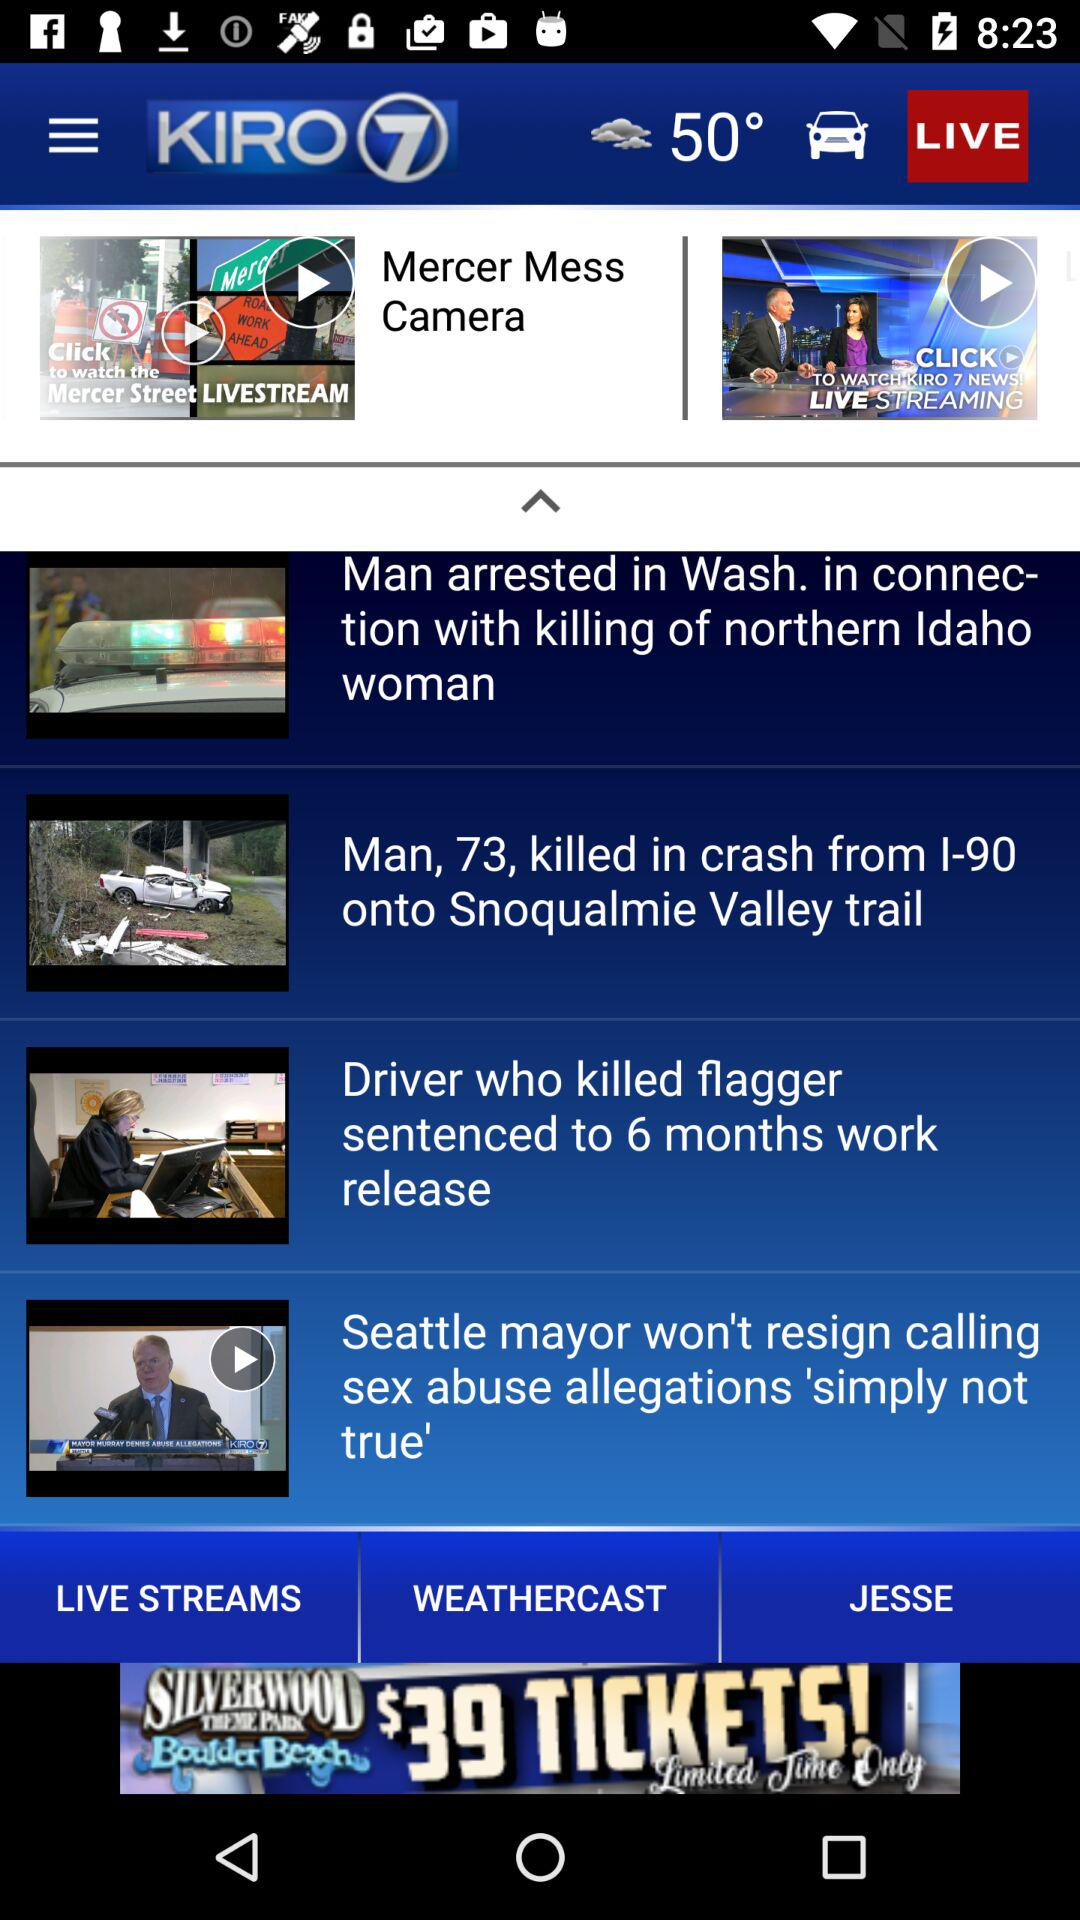What is the news channel's name? The news channel's name is "KIRO 7". 